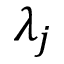Convert formula to latex. <formula><loc_0><loc_0><loc_500><loc_500>\lambda _ { j }</formula> 